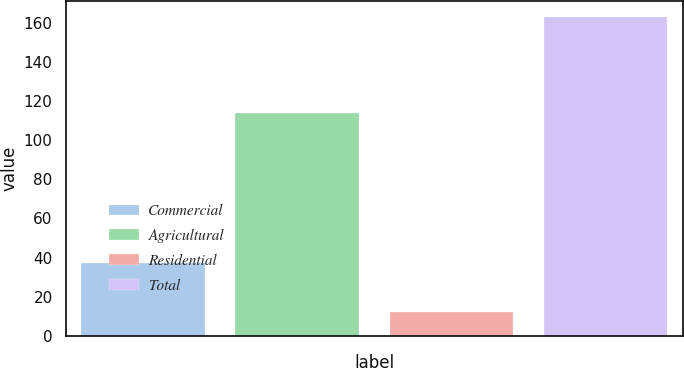Convert chart. <chart><loc_0><loc_0><loc_500><loc_500><bar_chart><fcel>Commercial<fcel>Agricultural<fcel>Residential<fcel>Total<nl><fcel>37<fcel>114<fcel>12<fcel>163<nl></chart> 